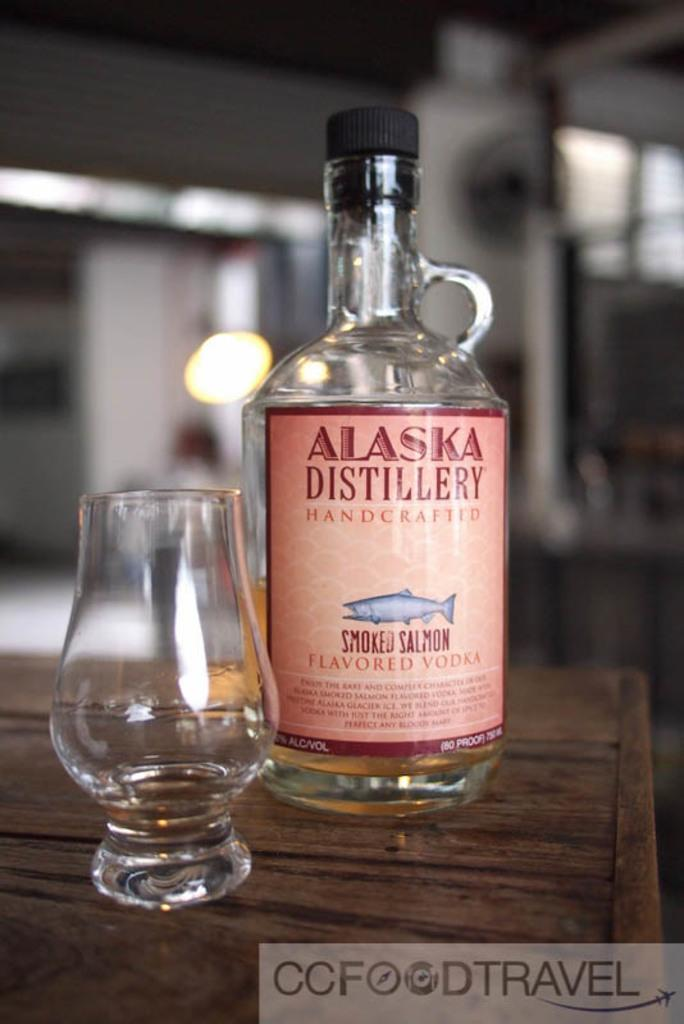<image>
Present a compact description of the photo's key features. a glass bottle that has a label that says 'alaska distillery' on it 